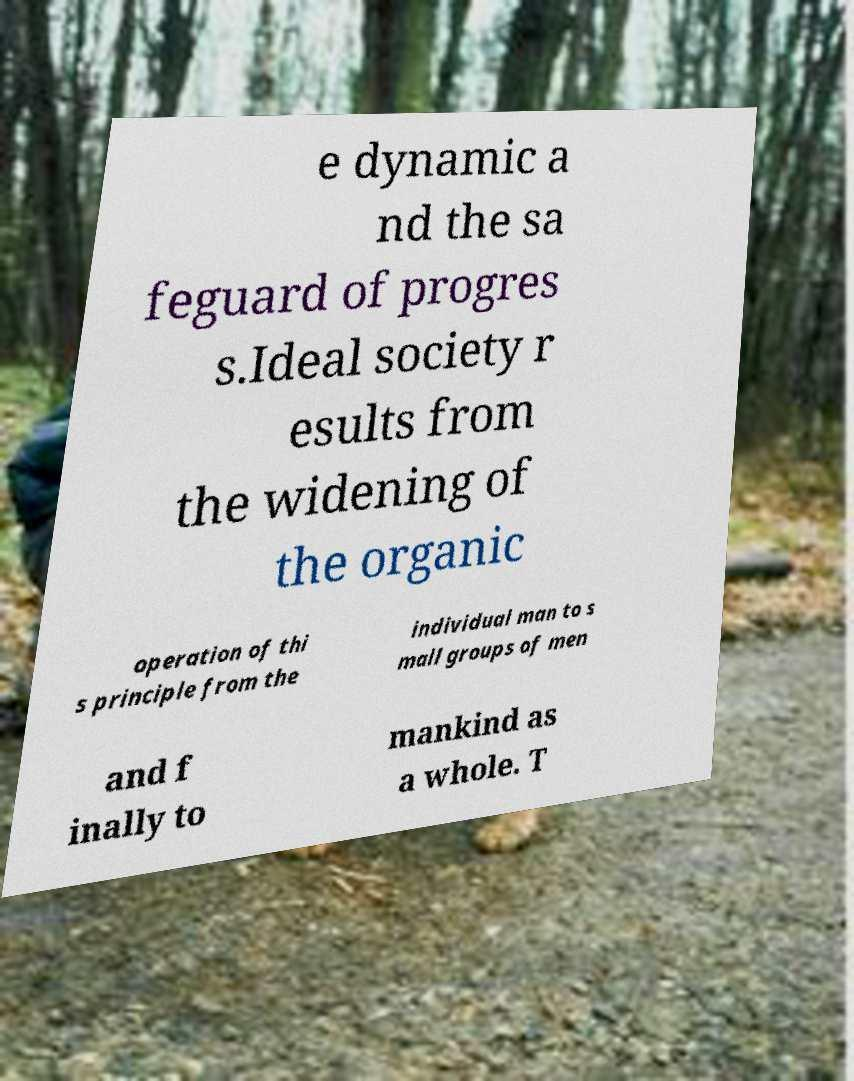I need the written content from this picture converted into text. Can you do that? e dynamic a nd the sa feguard of progres s.Ideal society r esults from the widening of the organic operation of thi s principle from the individual man to s mall groups of men and f inally to mankind as a whole. T 